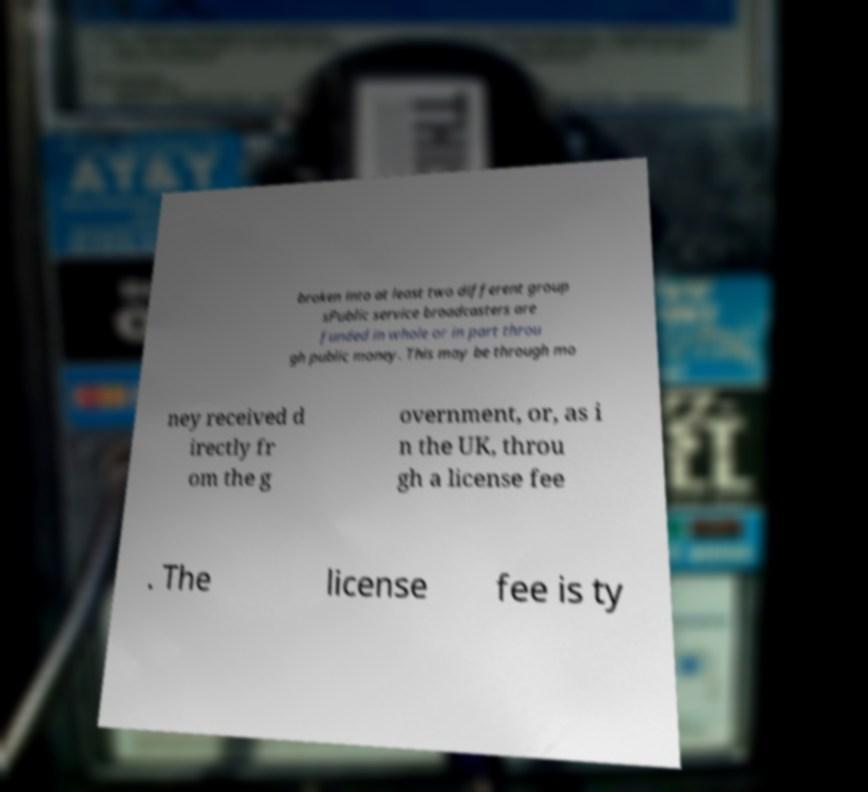Please read and relay the text visible in this image. What does it say? broken into at least two different group sPublic service broadcasters are funded in whole or in part throu gh public money. This may be through mo ney received d irectly fr om the g overnment, or, as i n the UK, throu gh a license fee . The license fee is ty 